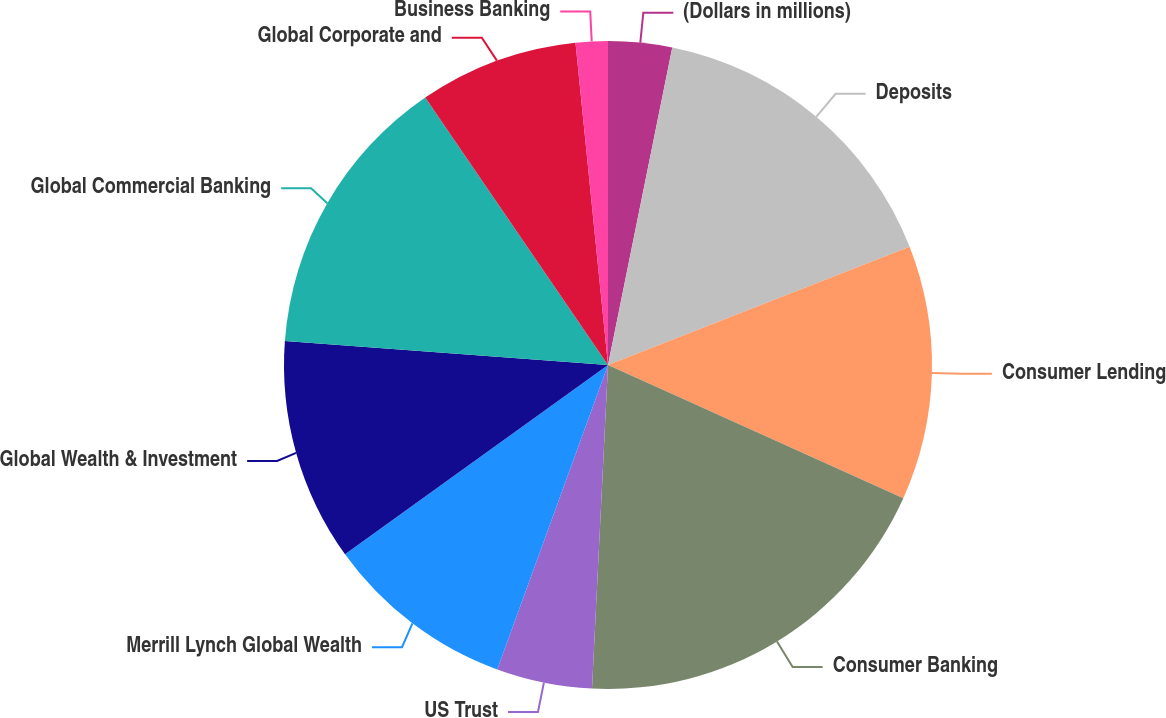<chart> <loc_0><loc_0><loc_500><loc_500><pie_chart><fcel>(Dollars in millions)<fcel>Deposits<fcel>Consumer Lending<fcel>Consumer Banking<fcel>US Trust<fcel>Merrill Lynch Global Wealth<fcel>Global Wealth & Investment<fcel>Global Commercial Banking<fcel>Global Corporate and<fcel>Business Banking<nl><fcel>3.18%<fcel>15.87%<fcel>12.7%<fcel>19.04%<fcel>4.77%<fcel>9.52%<fcel>11.11%<fcel>14.28%<fcel>7.94%<fcel>1.6%<nl></chart> 